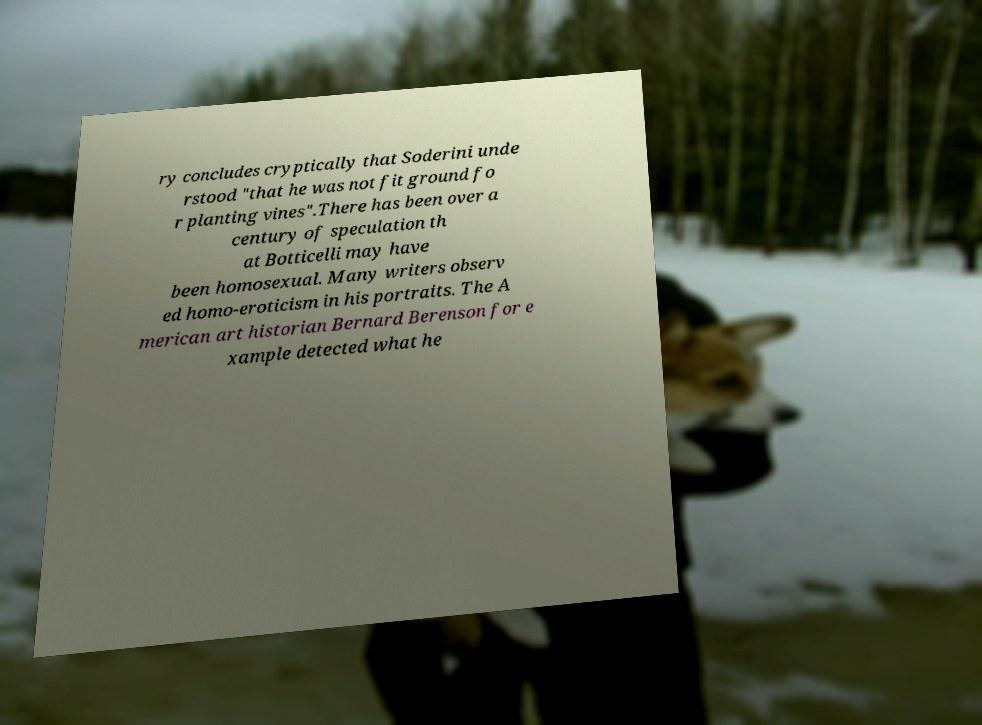Can you accurately transcribe the text from the provided image for me? ry concludes cryptically that Soderini unde rstood "that he was not fit ground fo r planting vines".There has been over a century of speculation th at Botticelli may have been homosexual. Many writers observ ed homo-eroticism in his portraits. The A merican art historian Bernard Berenson for e xample detected what he 